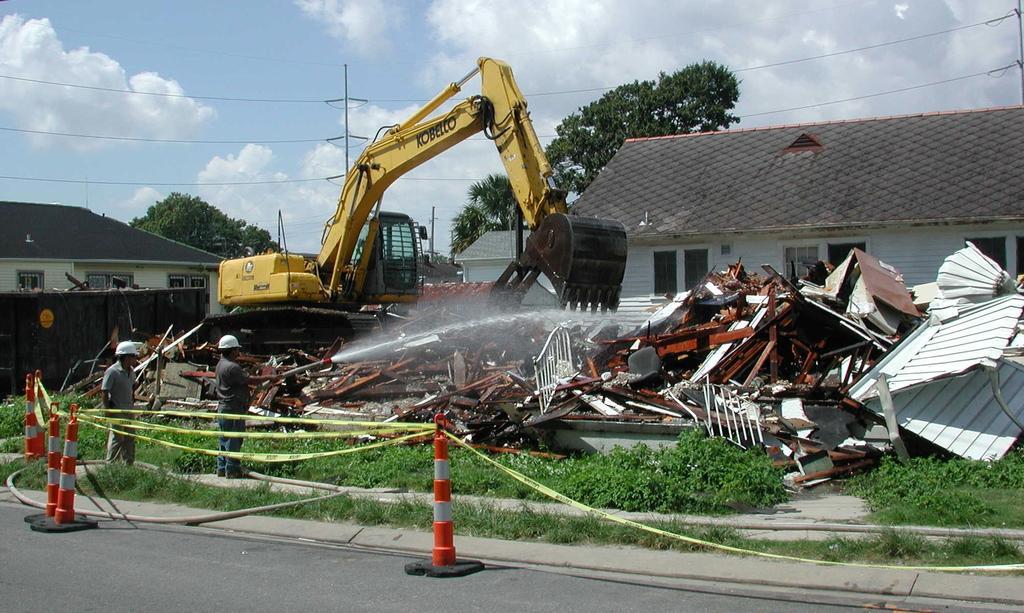Could you give a brief overview of what you see in this image? In this picture there is a yellow color jcb and there is a person holding a pipe from where the water is coming out from it and there are few broken objects in front of him and there is a house in the right corner and there is another house in the left corner and there are trees,poles and wires in the background. 